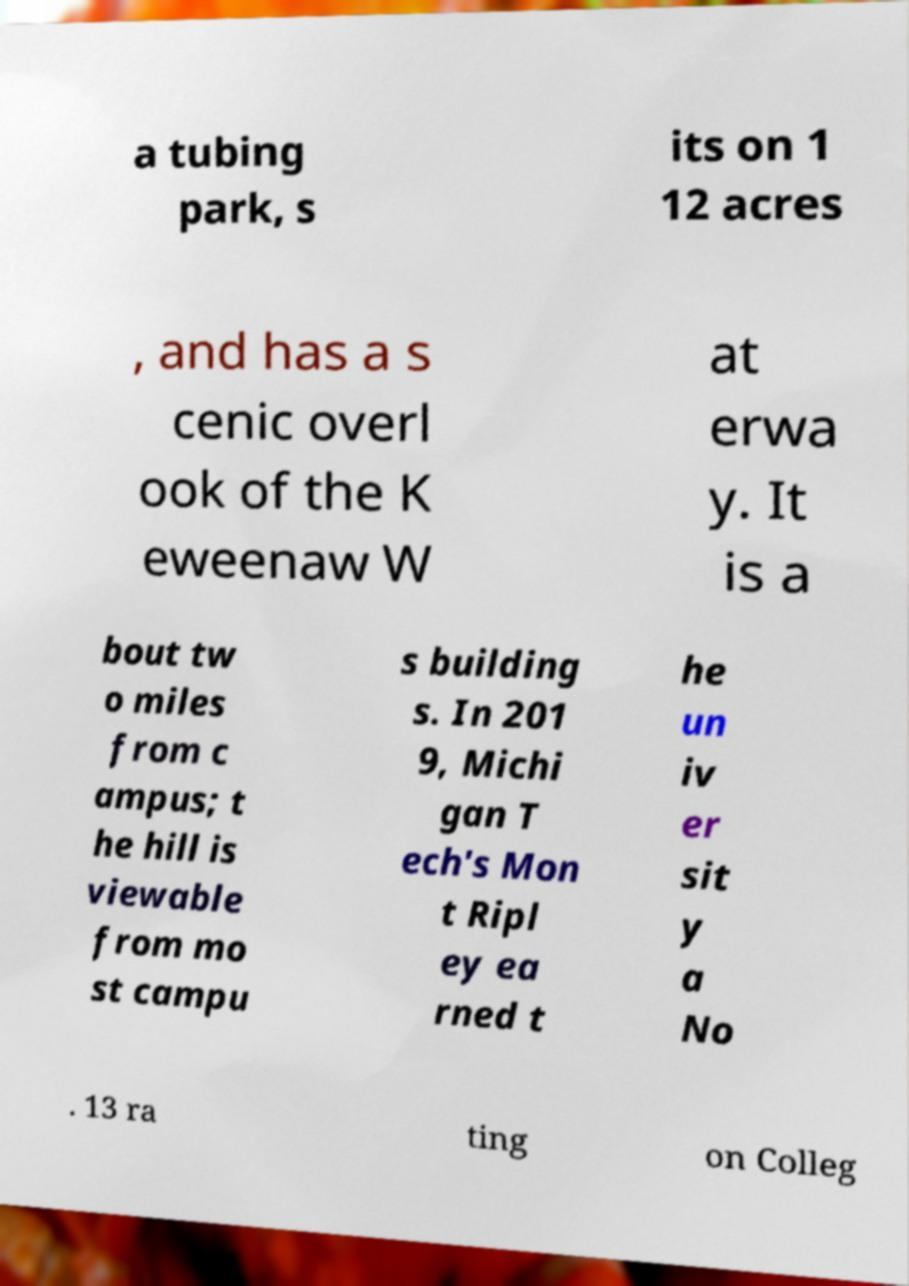For documentation purposes, I need the text within this image transcribed. Could you provide that? a tubing park, s its on 1 12 acres , and has a s cenic overl ook of the K eweenaw W at erwa y. It is a bout tw o miles from c ampus; t he hill is viewable from mo st campu s building s. In 201 9, Michi gan T ech's Mon t Ripl ey ea rned t he un iv er sit y a No . 13 ra ting on Colleg 